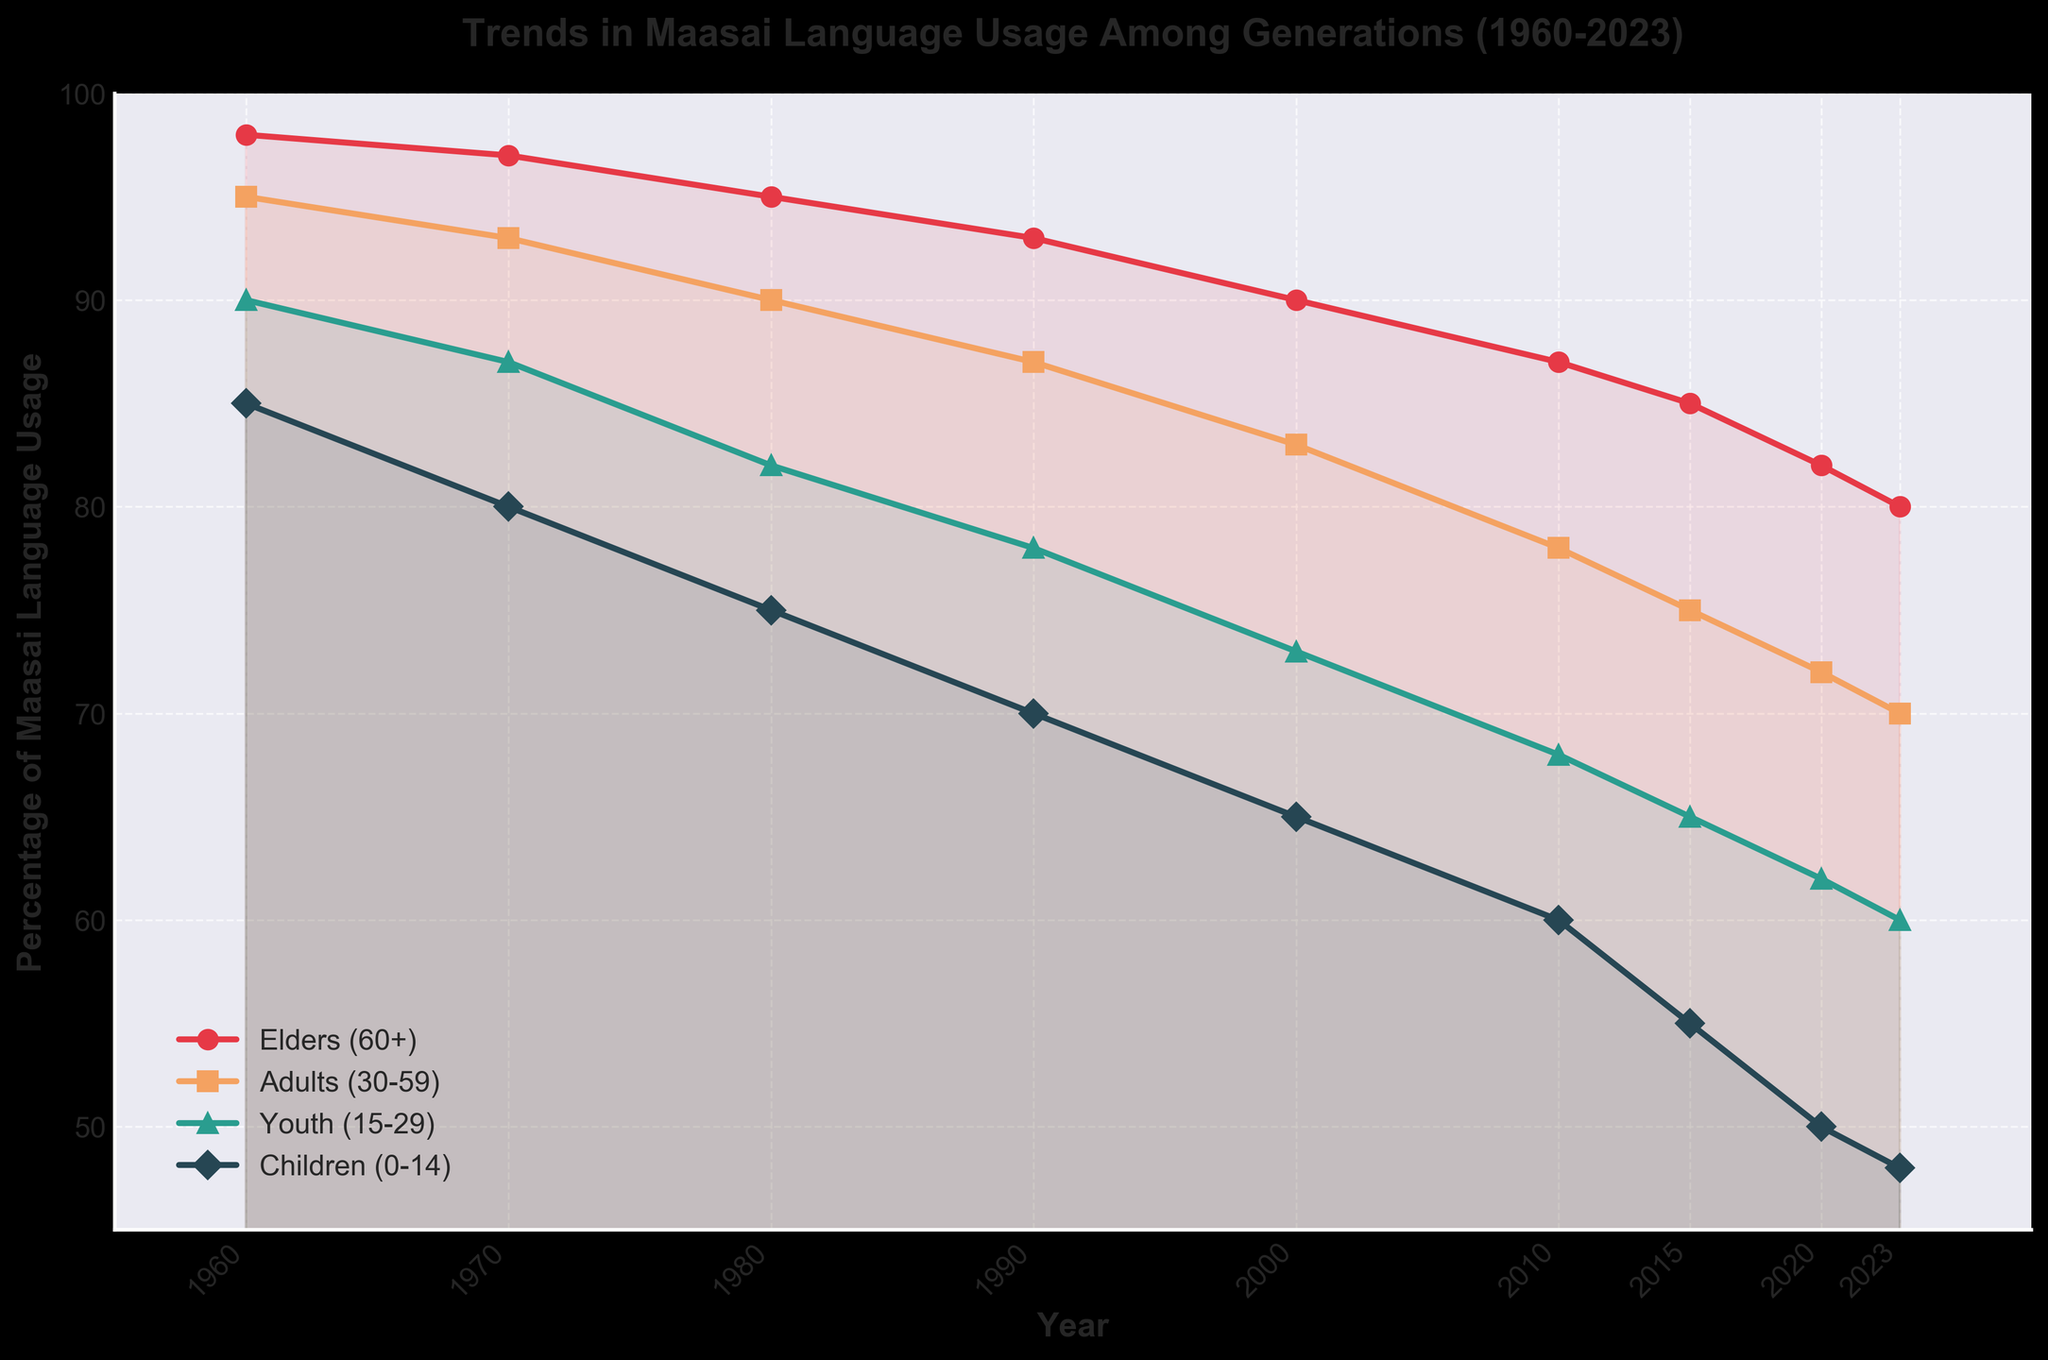What is the percentage of Maasai language usage by Elders (60+) in 2023? The plot shows that the percentage of Maasai language usage by Elders (60+) in 2023 is indicated by the value at the end of the line corresponding to this age group. The value reads as 80%.
Answer: 80% Which age group had the highest percentage of Maasai language usage in 1960? The plot displays different colored lines for each age group. In 1960, the Elders (60+) line is at the highest point compared to the other lines.
Answer: Elders (60+) What is the difference in Maasai language usage between Adults (30-59) and Youth (15-29) in 2000? Locate the points for Adults and Youth in the year 2000 on the plot. The Adults' usage is 83% while Youth's usage is 73%. The difference is 83 - 73 = 10%.
Answer: 10% In which year did the Youth (15-29) and Children (0-14) have the same percentage decrease from the previous decade? By examining the plot, we see both the Youth and Children lines decrease by 5% from the previous decades from 1990 to 2000. Youth decreases from 78% to 73% and Children from 70% to 65%.
Answer: 2000 What was the average percentage of Maasai language usage among all age groups in 2010? Average usage is calculated as: (Elders + Adults + Youth + Children) / 4. For 2010, it's (87 + 78 + 68 + 60) / 4 = 73.25%.
Answer: 73.25% Which age group experienced the steepest decline in Maasai language usage between 1960 and 2023? The steepest decline can be determined by comparing the drop between points across each age group's line. Children (0-14) dropped from 85% in 1960 to 48% in 2023, a decline of 37%, which is the largest drop.
Answer: Children (0-14) How did the Maasai language usage trend for Elders (60+) compare to that of Children (0-14) from 1960 to 2023? The plot shows both trends descending; however, the Elders' decline is more gradual compared to the steeper decline for Children.
Answer: Elders had a more gradual decline while Children had a steeper decline In 1980, which two generations had the closest usage percentages? By looking at the plot points for 1980, the percentages for Adults (90%) and Youth (82%) are closest to each other compared to other pairs of age groups.
Answer: Adults (30-59) and Youth (15-29) What visual attributes distinguish the line representing Children's Maasai language usage? The line representing Children (0-14) is visually notable by its green color and diamond-shaped markers.
Answer: Green line with diamond-shaped markers 